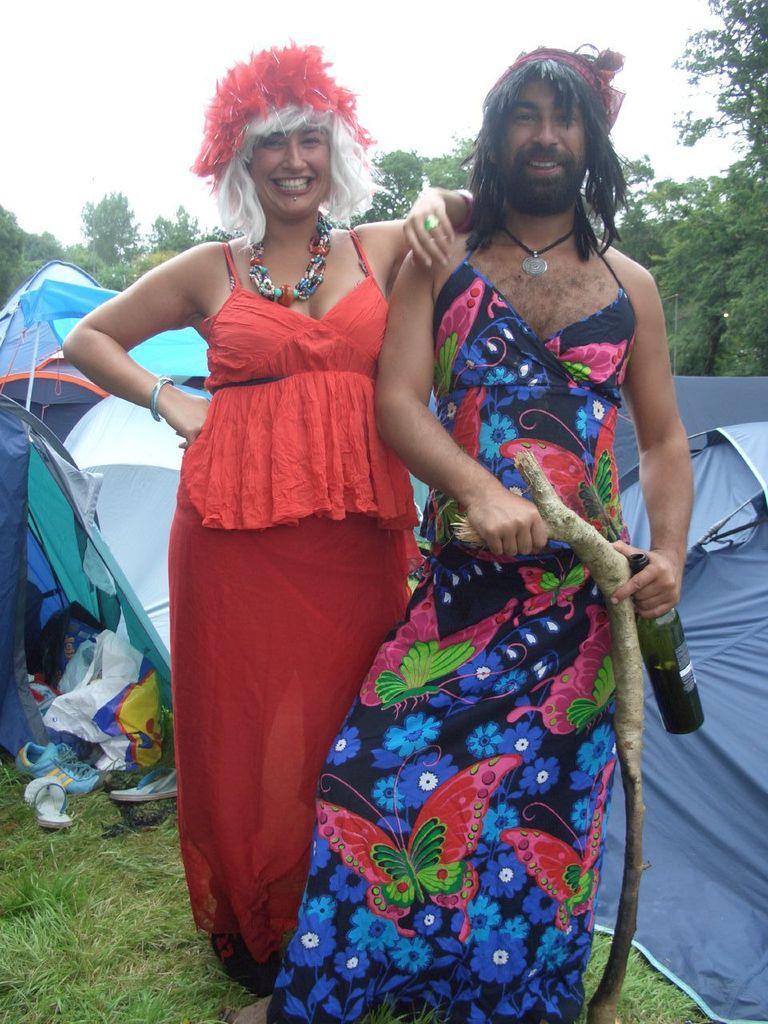Please provide a concise description of this image. This image is clicked outside. There are two persons in the middle. They are wearing same costume. There are tents in the middle. There are trees in the middle. There is grass at the bottom. One of them is holding a bottle and a stick. There is sky at the top. 